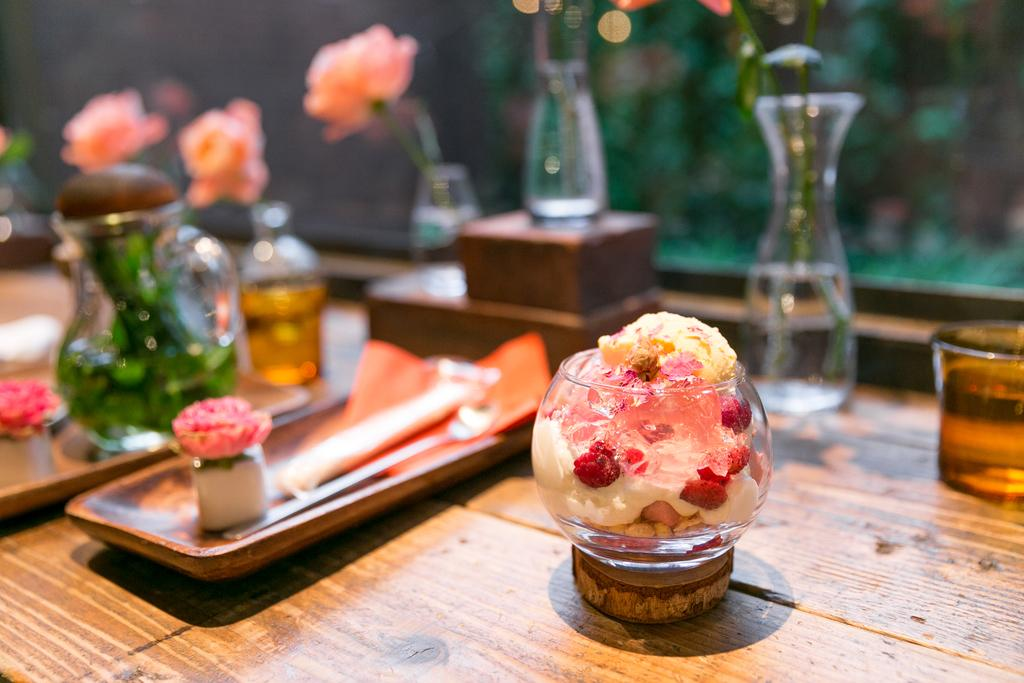What type of container is visible in the image? There is a glass bottle in the image. What else can be seen on the table in the image? There are other objects on the table in the image, but their specific details are not provided. How many girls are present in the image? There is no information about girls in the image, as the facts only mention a glass bottle and other objects on the table. 